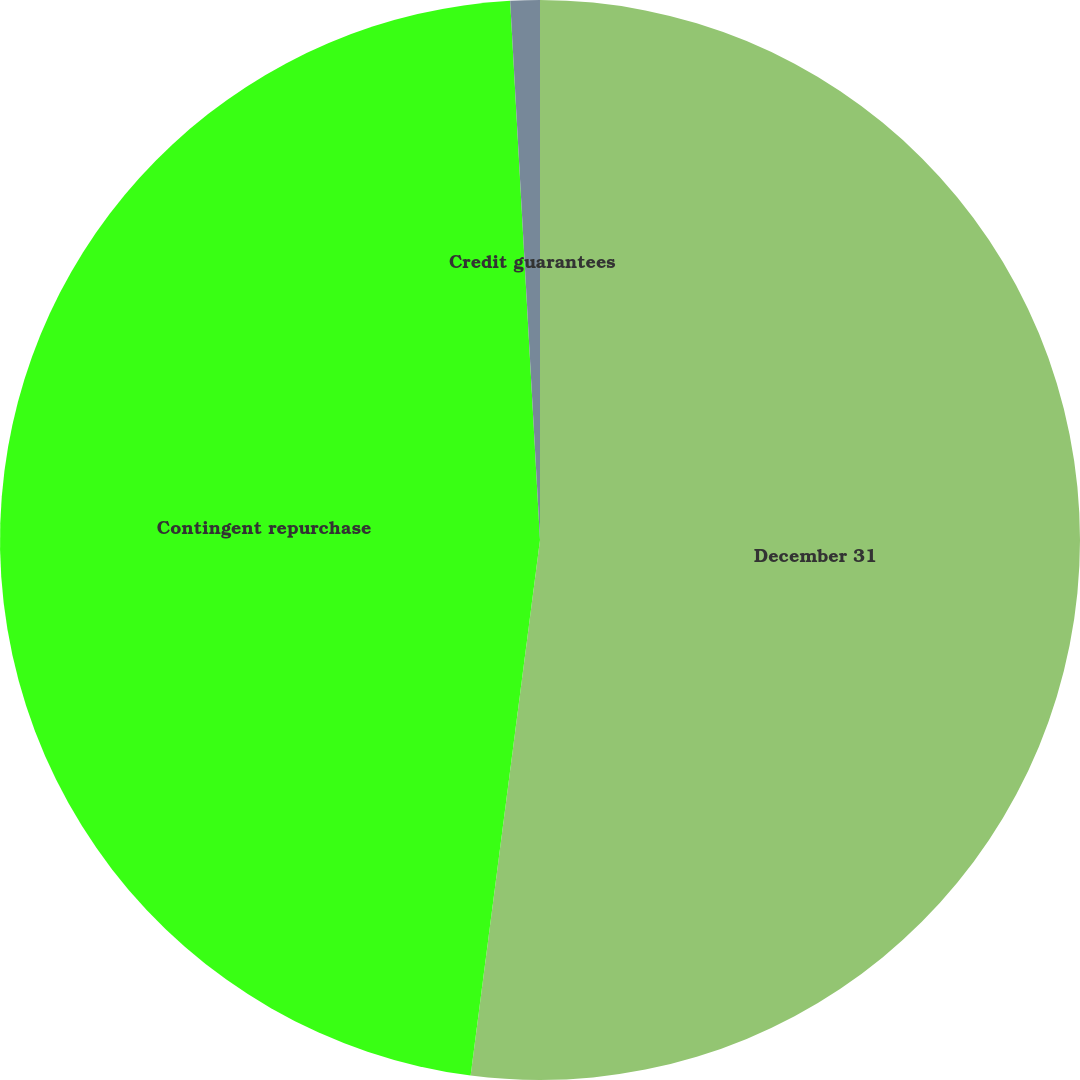Convert chart to OTSL. <chart><loc_0><loc_0><loc_500><loc_500><pie_chart><fcel>December 31<fcel>Contingent repurchase<fcel>Credit guarantees<nl><fcel>52.05%<fcel>47.07%<fcel>0.88%<nl></chart> 